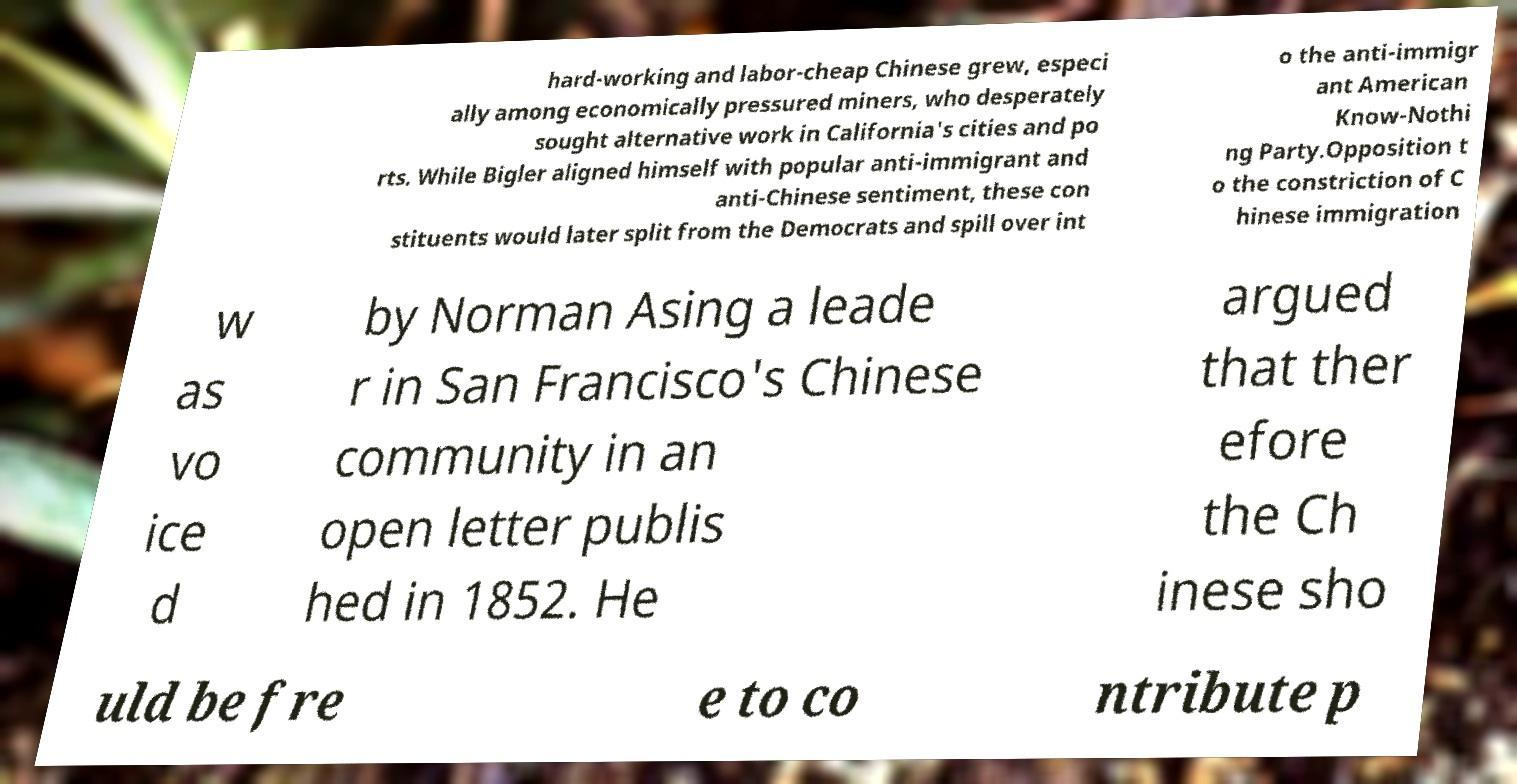What messages or text are displayed in this image? I need them in a readable, typed format. hard-working and labor-cheap Chinese grew, especi ally among economically pressured miners, who desperately sought alternative work in California's cities and po rts. While Bigler aligned himself with popular anti-immigrant and anti-Chinese sentiment, these con stituents would later split from the Democrats and spill over int o the anti-immigr ant American Know-Nothi ng Party.Opposition t o the constriction of C hinese immigration w as vo ice d by Norman Asing a leade r in San Francisco's Chinese community in an open letter publis hed in 1852. He argued that ther efore the Ch inese sho uld be fre e to co ntribute p 